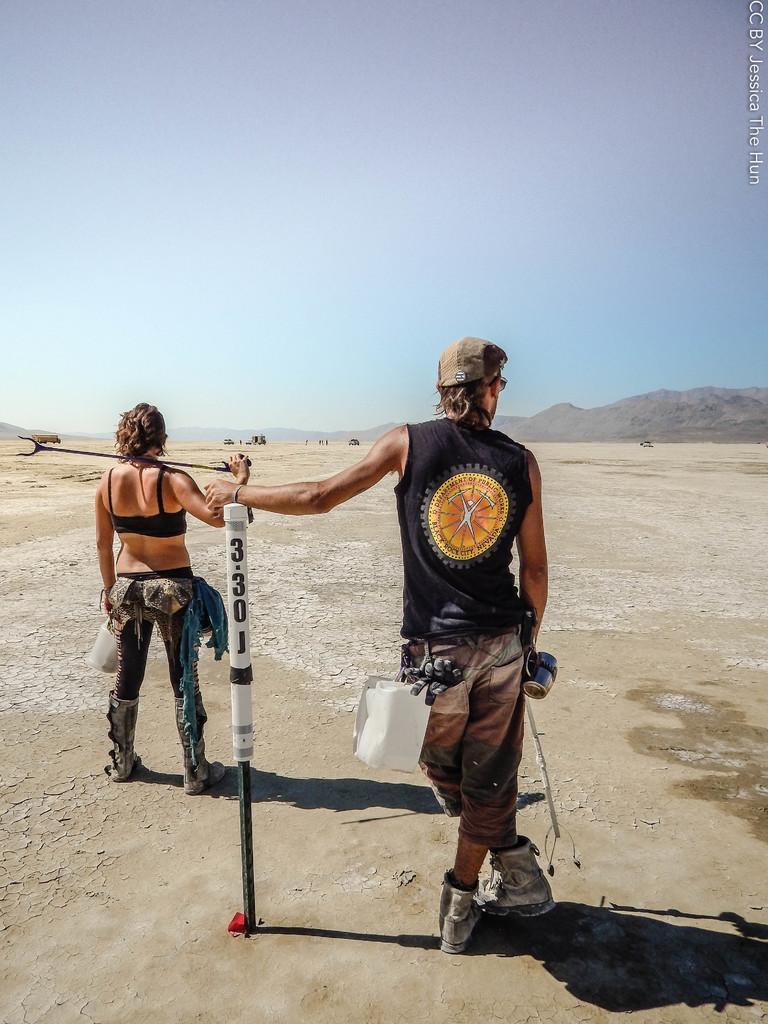Can you describe this image briefly? In this picture there is a man and woman standing and holding sticks, beside him we can see a pole and we can see ground. In the background of the image we can see a vehicle, hill and sky. In the top right side of the image we can see text. 